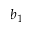Convert formula to latex. <formula><loc_0><loc_0><loc_500><loc_500>b _ { 1 }</formula> 